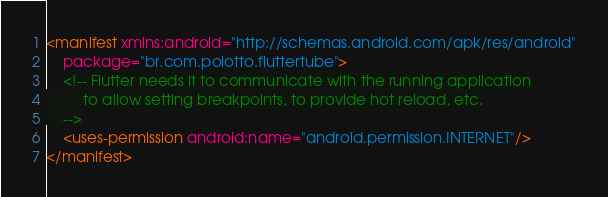<code> <loc_0><loc_0><loc_500><loc_500><_XML_><manifest xmlns:android="http://schemas.android.com/apk/res/android"
    package="br.com.polotto.fluttertube">
    <!-- Flutter needs it to communicate with the running application
         to allow setting breakpoints, to provide hot reload, etc.
    -->
    <uses-permission android:name="android.permission.INTERNET"/>
</manifest>
</code> 